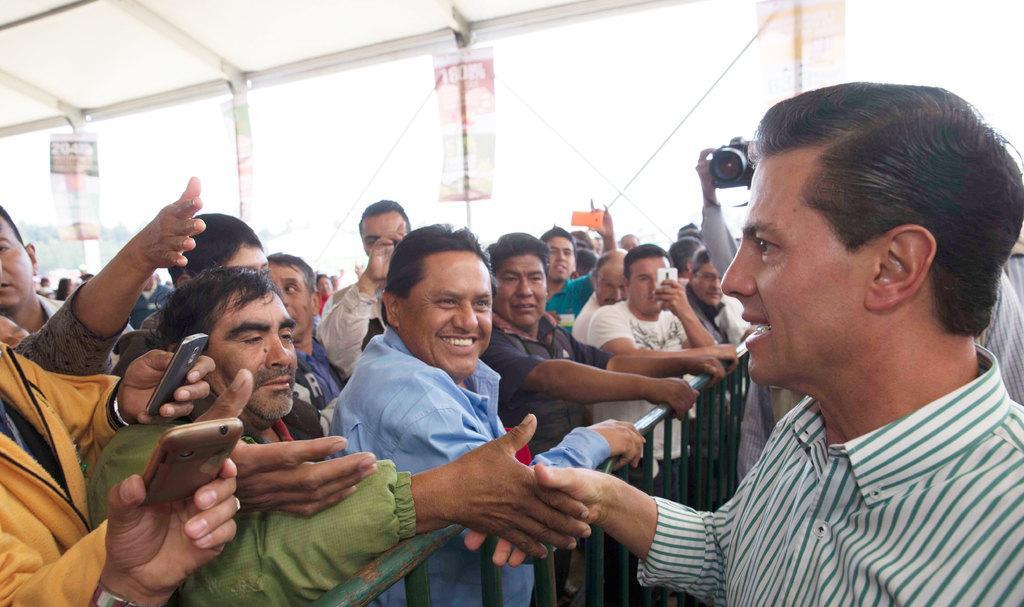How would you summarize this image in a sentence or two? In the foreground of this image, on the right, there is a man and behind him, there are persons standing and a man holding camera. On the left, there are persons standing behind the railing and a man shaking hand. In the background, under the shelter, there are banners and ropes and the sunny sky. 